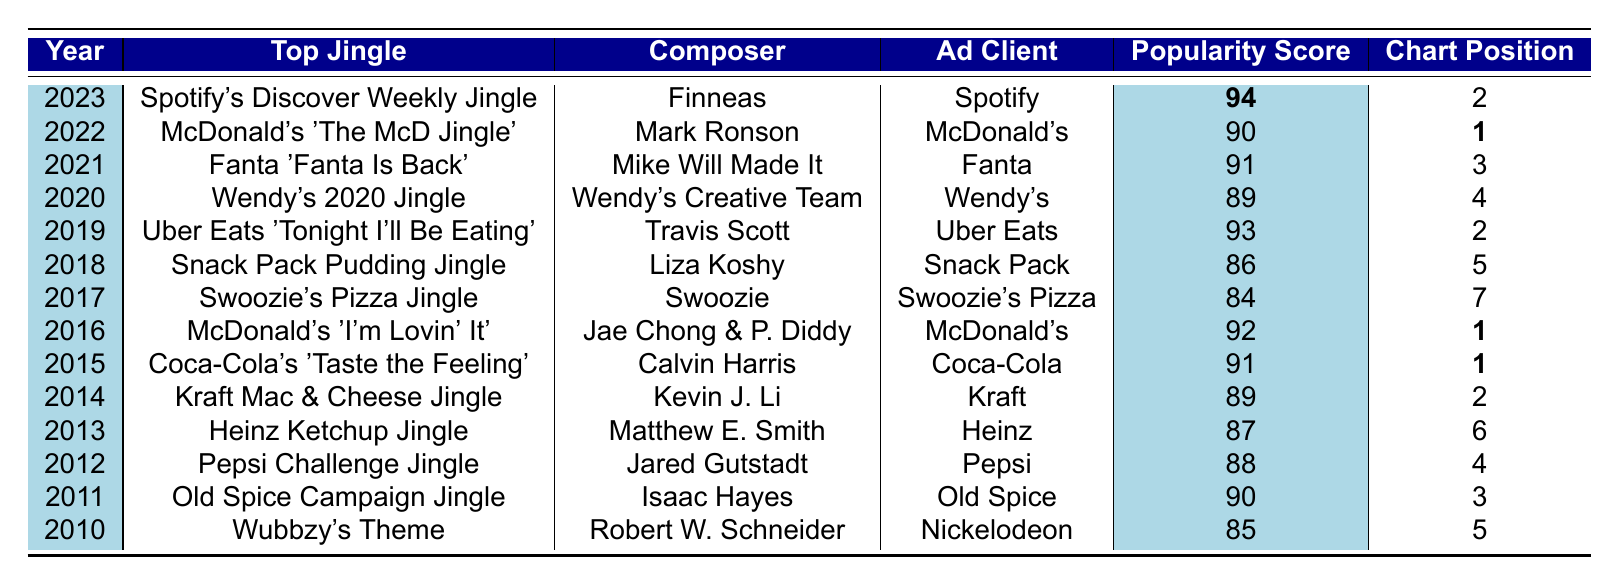What was the top jingle in 2021? According to the table, the top jingle for the year 2021 is "Fanta 'Fanta Is Back'."
Answer: Fanta 'Fanta Is Back' Which year had the highest popularity score? By scanning the table for the highest value in the Popularity Score column, 2023 has the highest score of 94.
Answer: 2023 What are the YouTube views for McDonald's 'The McD Jingle'? The table indicates that the YouTube views for McDonald's 'The McD Jingle' in 2022 is 7,500,000.
Answer: 7,500,000 How many jingles had a popularity score of 90 or above? There are 5 jingles with a popularity score of 90 or above: 2011 (90), 2015 (91), 2016 (92), 2019 (93), and 2023 (94).
Answer: 5 What is the average popularity score of the jingles from 2010 to 2015? To calculate the average, sum the popularity scores from 2010 to 2015: (85 + 90 + 88 + 87 + 89 + 91) = 520. Then, divide by the number of entries (6) to get 520 / 6 = 86.67.
Answer: 86.67 Did any jingle released in 2017 or later have a lower popularity score than the top jingle in 2010? The top jingle in 2010 has a popularity score of 85. The jingles from 2017 (84) and 2018 (86) both have scores, but only the 2017 jingle is below 85, making the statement true.
Answer: Yes Which jingle had the most YouTube views and what was that view count? The jingle with the most YouTube views is McDonald's 'I'm Lovin' It' from 2016, with a total of 20,000,000 views.
Answer: 20,000,000 What is the difference in popularity scores between the top jingles of 2015 and 2016? The popularity score of the 2015 jingle (91) minus the score of the 2016 jingle (92) results in a difference of -1.
Answer: -1 Is there a jingle from 2014 that has the same chart position as the jingle from 2023? The jingle from 2014, Kraft Mac & Cheese Jingle, has a chart position of 2, which is the same as the jingle from 2023, Spotify's Discover Weekly Jingle. Thus, the answer is true.
Answer: Yes What is the total number of YouTube views for all jingles from 2010 to 2012? Summing the YouTube views: 2,500,000 (2010) + 18,000,000 (2011) + 12,000,000 (2012) equals 32,500,000 views in total.
Answer: 32,500,000 